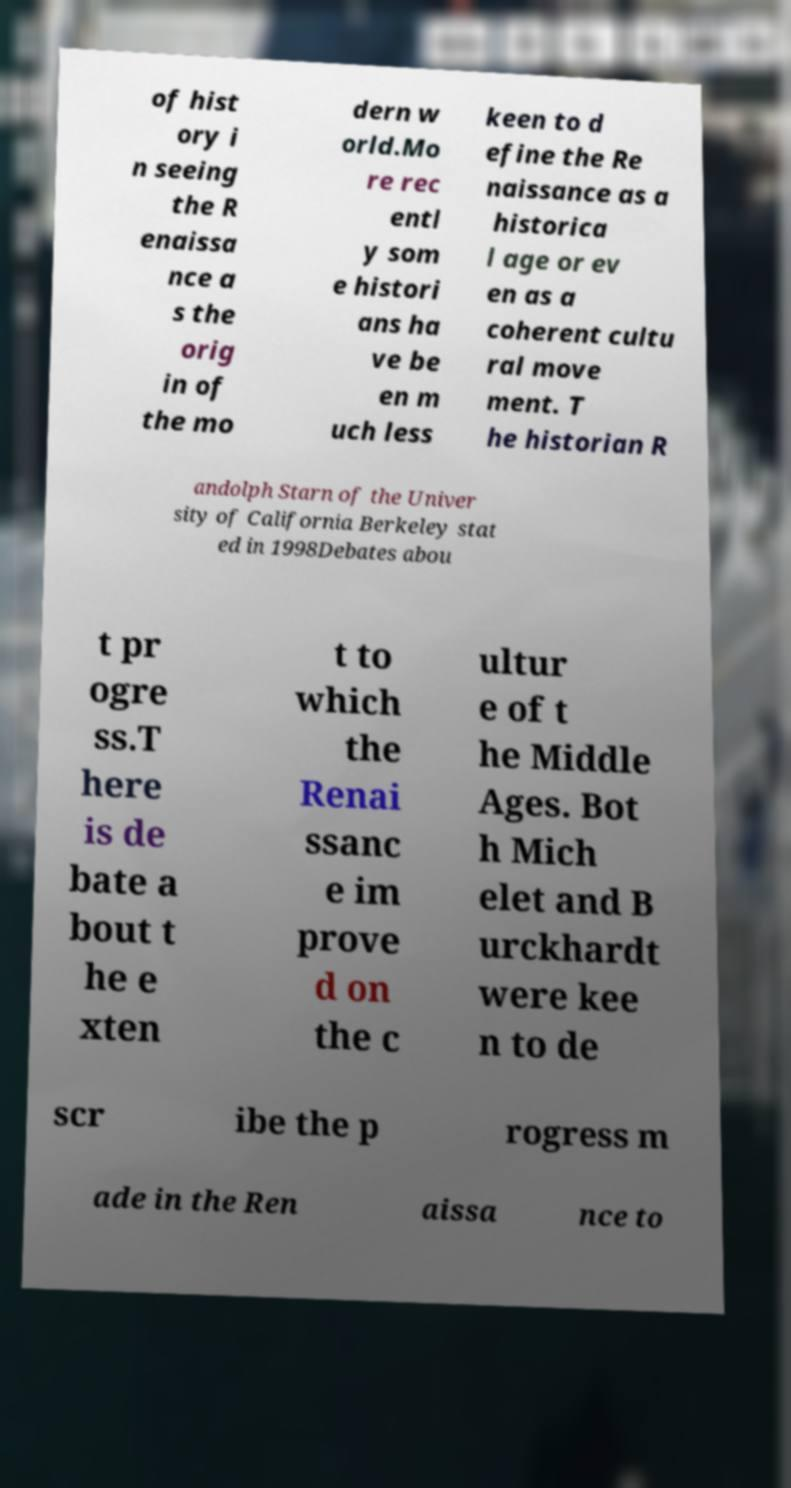There's text embedded in this image that I need extracted. Can you transcribe it verbatim? of hist ory i n seeing the R enaissa nce a s the orig in of the mo dern w orld.Mo re rec entl y som e histori ans ha ve be en m uch less keen to d efine the Re naissance as a historica l age or ev en as a coherent cultu ral move ment. T he historian R andolph Starn of the Univer sity of California Berkeley stat ed in 1998Debates abou t pr ogre ss.T here is de bate a bout t he e xten t to which the Renai ssanc e im prove d on the c ultur e of t he Middle Ages. Bot h Mich elet and B urckhardt were kee n to de scr ibe the p rogress m ade in the Ren aissa nce to 